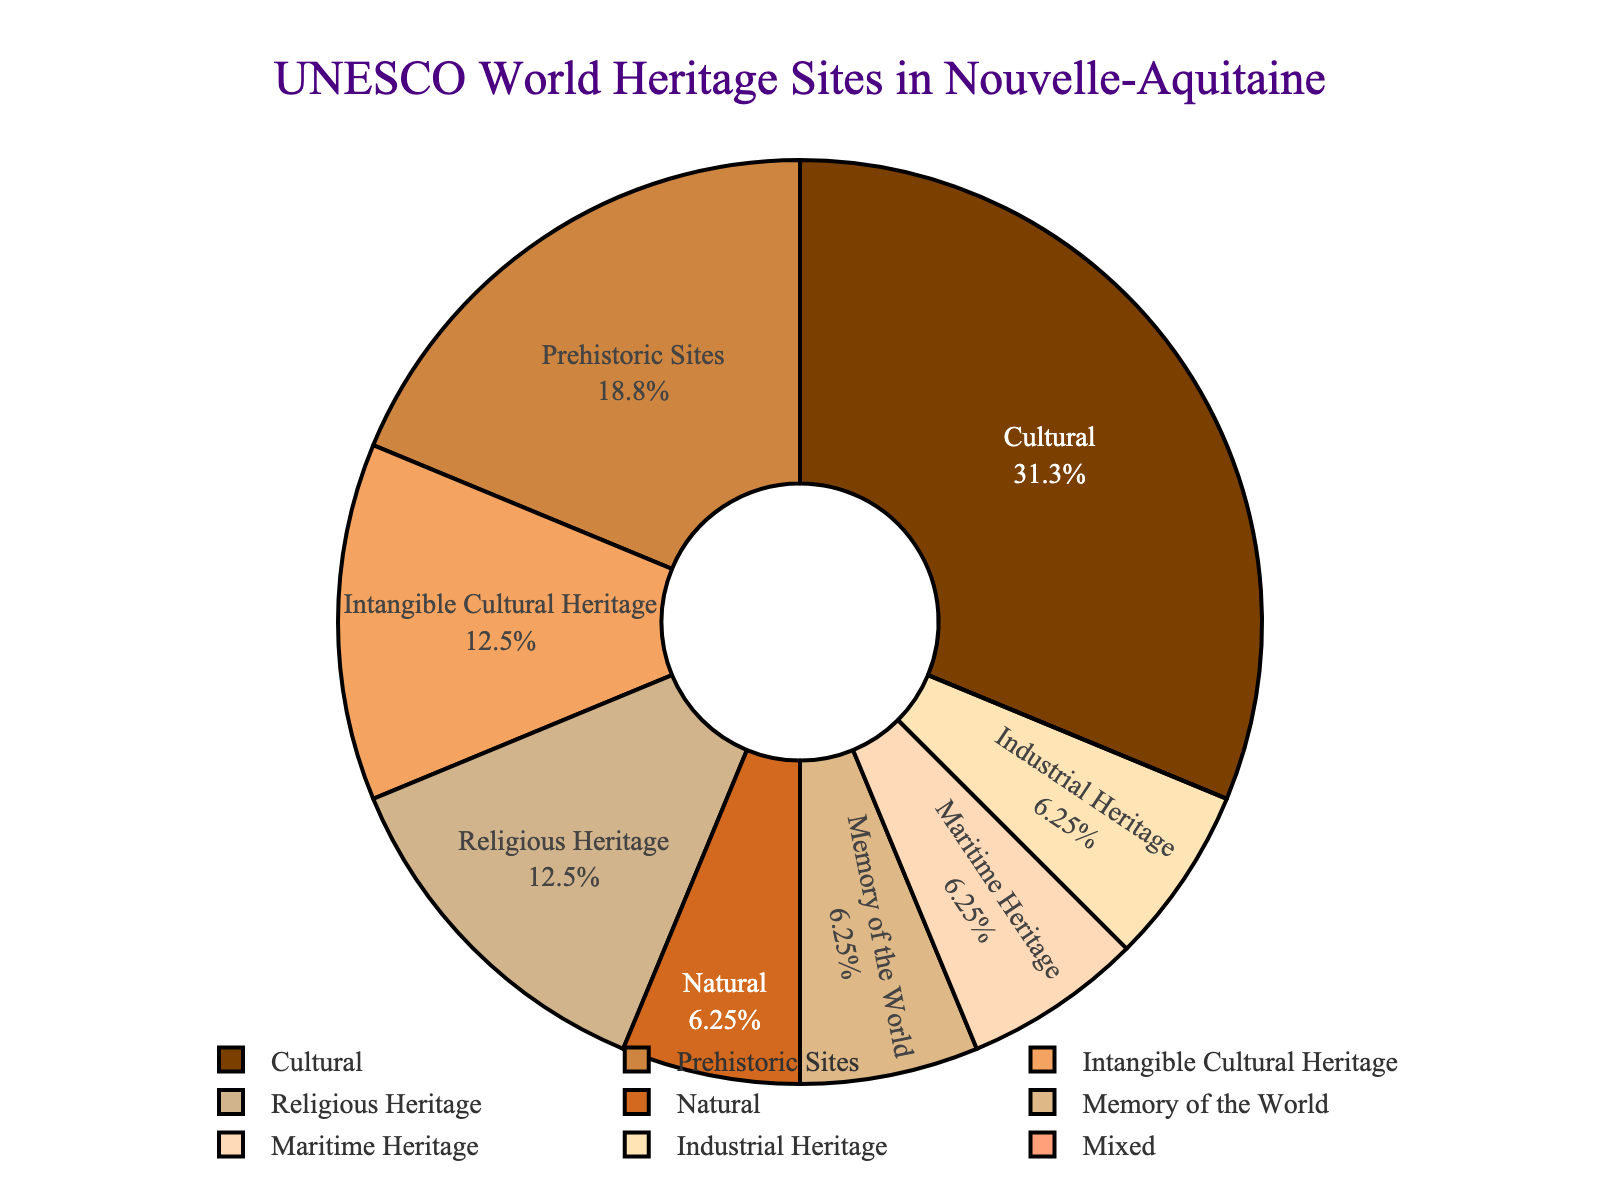Which category has the highest number of UNESCO World Heritage Sites in Nouvelle-Aquitaine? To answer this, we need to look at the segment in the pie chart with the largest size. "Cultural" has the highest number with 5 sites.
Answer: Cultural How many UNESCO World Heritage Sites are classified as Religious Heritage? We need to find the segment labeled "Religious Heritage" on the pie chart and check the corresponding number. It shows 2 sites.
Answer: 2 Is the number of Cultural sites greater than the total of Religious Heritage and Prehistoric Sites combined? Firstly, sum the numbers of Religious Heritage (2) and Prehistoric Sites (3), which totals 5. The number of Cultural sites is also 5. Therefore, they are equal.
Answer: No What percentage of the UNESCO World Heritage Sites in Nouvelle-Aquitaine are Natural sites? Look at the "Natural" category on the pie chart to determine its proportion relative to the total number of sites. There is 1 Natural site out of a total of 16 sites. The percentage is (1/16)*100, which is 6.25%.
Answer: 6.25% Which type of heritage has the least representation, and how many sites does it have? The pie chart shows the smallest segment for "Mixed," which has 0 sites.
Answer: Mixed, 0 How many more Cultural sites are there compared to Maritime Heritage sites? The pie chart indicates that there are 5 Cultural sites and 1 Maritime Heritage site. The difference is 5 - 1 = 4.
Answer: 4 Are there more Intangible Cultural Heritage sites or Memory of the World sites? Intangible Cultural Heritage has 2 sites, while Memory of the World has 1 site. Intangible Cultural Heritage has more.
Answer: Intangible Cultural Heritage What is the combined percentage of Industrial Heritage and Maritime Heritage UNESCO World Heritage Sites? By visually assessing the pie chart, Industrial Heritage and Maritime Heritage each have 1 site. Together, they account for 1 + 1 = 2 sites out of 16 total. The combined percentage is (2/16)*100, which is 12.5%.
Answer: 12.5% How many categories have at least 2 UNESCO World Heritage Sites? Count the categories with numbers 2 or above: Cultural (5), Intangible Cultural Heritage (2), Prehistoric Sites (3), and Religious Heritage (2). There are 4 categories in total.
Answer: 4 What is the difference in the number of sites between the most common and the least common categories? The most common category is Cultural with 5 sites. The least common category is Mixed with 0 sites. The difference is 5 - 0 = 5.
Answer: 5 